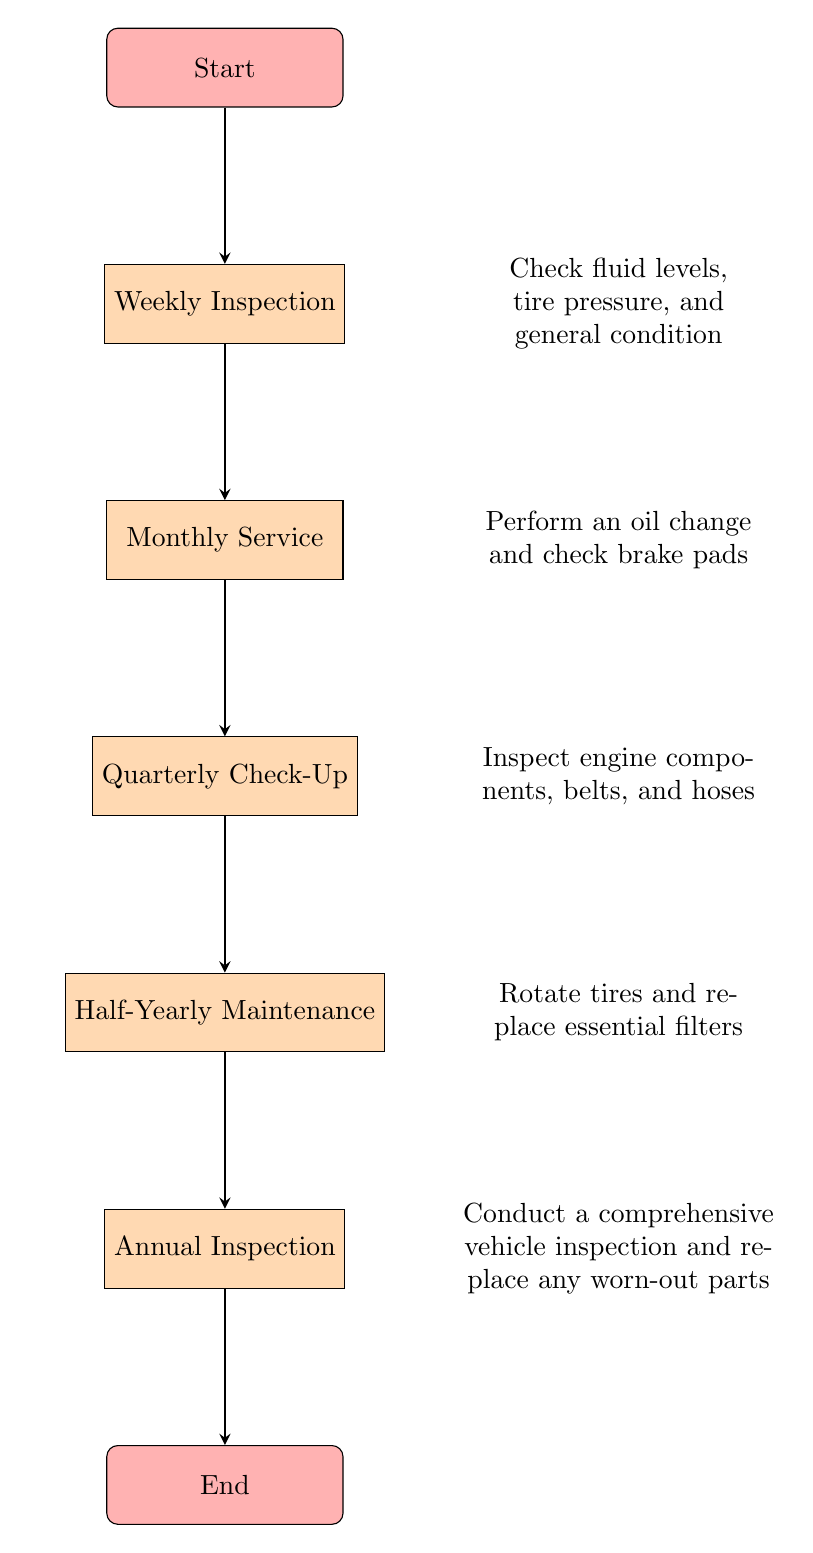What is the first node in the flow chart? The first node in the flow chart is labeled "Start".
Answer: Start How many total tasks are in the maintenance schedule? There are five task nodes listed in the maintenance schedule: Weekly Inspection, Monthly Service, Quarterly Check-Up, Half-Yearly Maintenance, and Annual Inspection.
Answer: 5 What must be checked during the Weekly Inspection? During the Weekly Inspection, fluid levels, tire pressure, and general condition must be checked.
Answer: Fluid levels, tire pressure, general condition What is the last task before completing the flow chart? The last task before completing the flow chart is "Annual Inspection".
Answer: Annual Inspection Which task involves rotating tires? The task that involves rotating tires is "Half-Yearly Maintenance".
Answer: Half-Yearly Maintenance What is the relationship between the "Monthly Service" and "Quarterly Check-Up" nodes? The relationship is sequential; you proceed from "Monthly Service" to "Quarterly Check-Up" as part of the maintenance schedule.
Answer: Proceed What is included in the details of the Annual Inspection? The details of the Annual Inspection include conducting a comprehensive vehicle inspection and replacing any worn-out parts.
Answer: Comprehensive vehicle inspection and replacing worn-out parts How many edges connect the nodes in the chart? There are six edges connecting the nodes in the chart, as each process node is linked sequentially from start to end.
Answer: 6 What is the purpose of the Half-Yearly Maintenance task? The purpose of the Half-Yearly Maintenance task is to rotate tires and replace essential filters.
Answer: Rotate tires and replace essential filters 